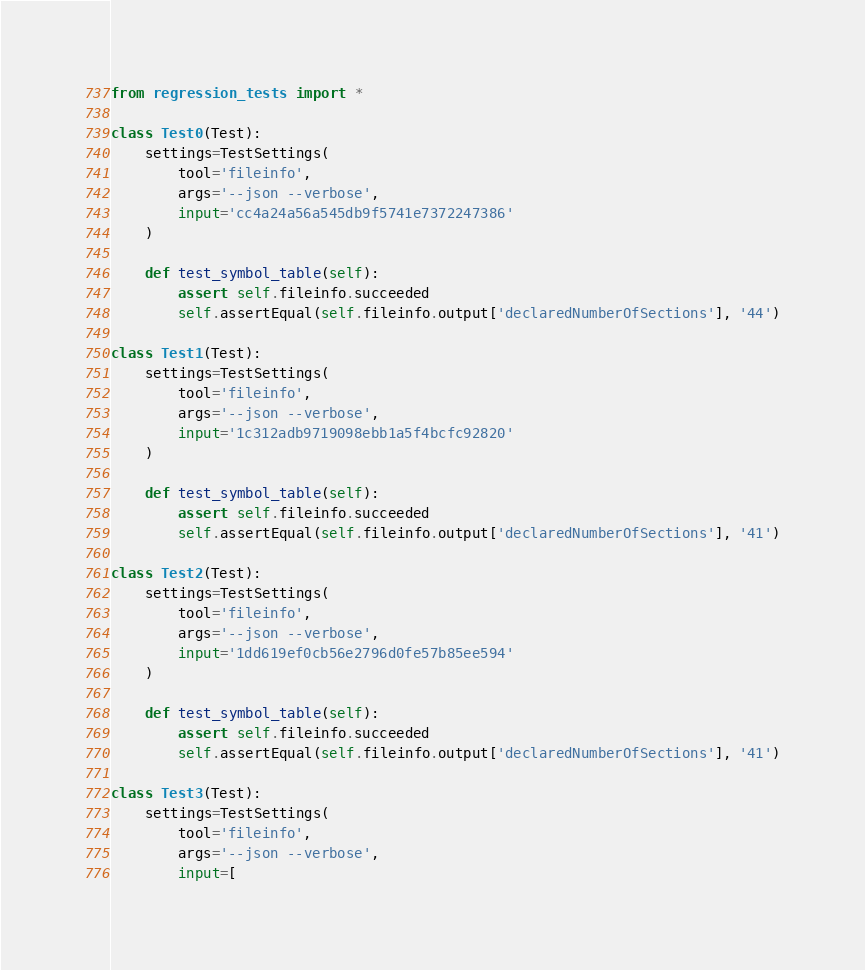<code> <loc_0><loc_0><loc_500><loc_500><_Python_>from regression_tests import *

class Test0(Test):
    settings=TestSettings(
        tool='fileinfo',
        args='--json --verbose',
        input='cc4a24a56a545db9f5741e7372247386'
    )

    def test_symbol_table(self):
        assert self.fileinfo.succeeded
        self.assertEqual(self.fileinfo.output['declaredNumberOfSections'], '44')

class Test1(Test):
    settings=TestSettings(
        tool='fileinfo',
        args='--json --verbose',
        input='1c312adb9719098ebb1a5f4bcfc92820'
    )

    def test_symbol_table(self):
        assert self.fileinfo.succeeded
        self.assertEqual(self.fileinfo.output['declaredNumberOfSections'], '41')

class Test2(Test):
    settings=TestSettings(
        tool='fileinfo',
        args='--json --verbose',
        input='1dd619ef0cb56e2796d0fe57b85ee594'
    )

    def test_symbol_table(self):
        assert self.fileinfo.succeeded
        self.assertEqual(self.fileinfo.output['declaredNumberOfSections'], '41')

class Test3(Test):
    settings=TestSettings(
        tool='fileinfo',
        args='--json --verbose',
        input=[</code> 